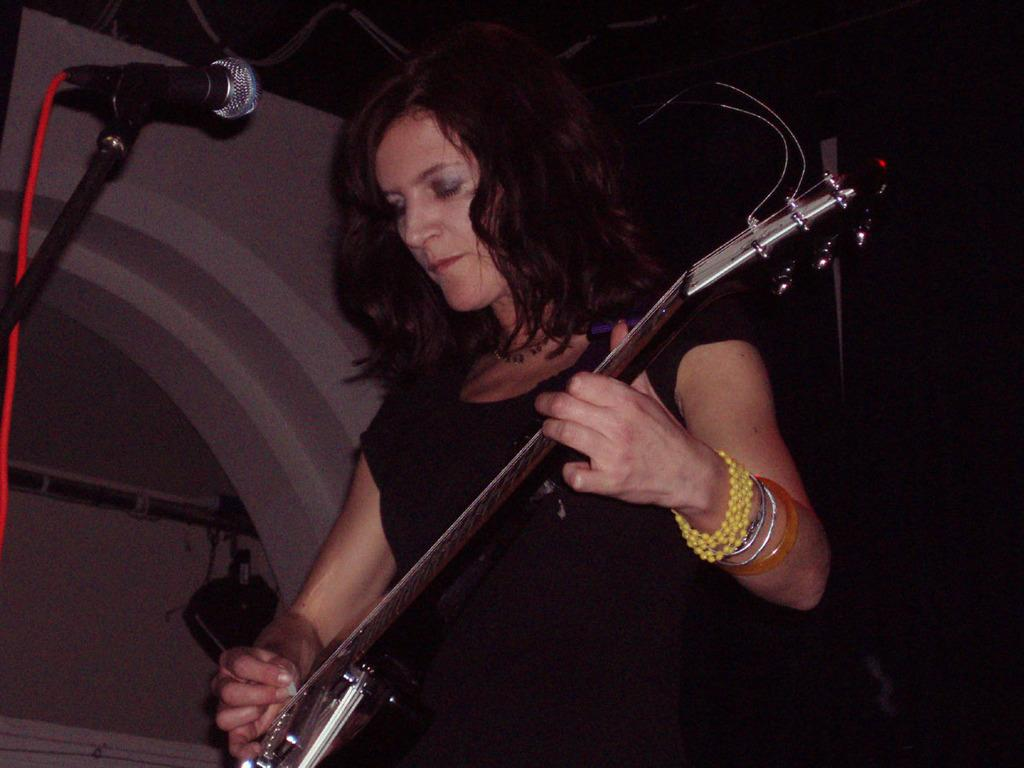What is the lady in the image doing? The lady is playing guitar. What is the lady wearing in the image? The lady is wearing a black top. What object is in front of the lady? There is a microphone in front of her. How many visitors can be seen in the image? There are no visitors present in the image; it only features the lady playing guitar. What type of disease is the lady suffering from in the image? There is no indication of any disease in the image; the lady is playing guitar and appears to be in good health. 